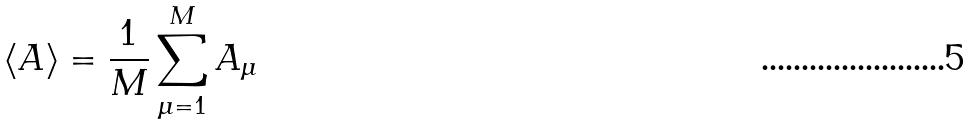Convert formula to latex. <formula><loc_0><loc_0><loc_500><loc_500>\langle A \rangle = \frac { 1 } { M } \sum _ { \mu = 1 } ^ { M } A _ { \mu }</formula> 